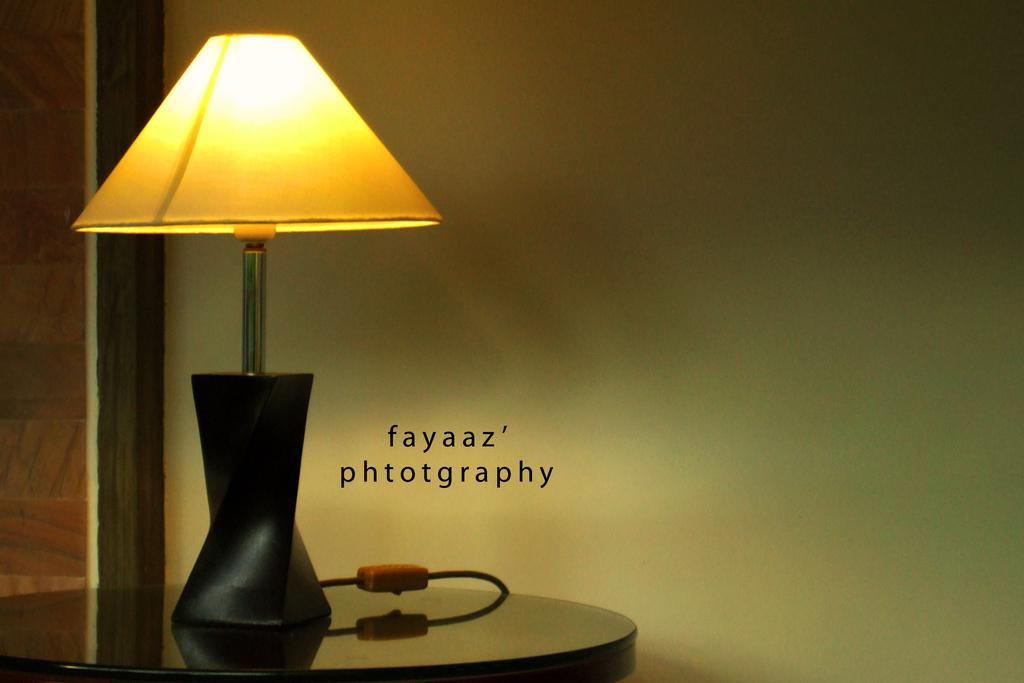What object is placed on the table in the image? There is a lamp on the table. What is written or depicted beside the lamp? There is some text beside the lamp. What can be seen in the background of the image? There is a wall in the background. How is the lamp powered or connected? The lamp is connected with a wire. What type of lettuce is being used as a footrest in the image? There is no lettuce or footrest present in the image. 